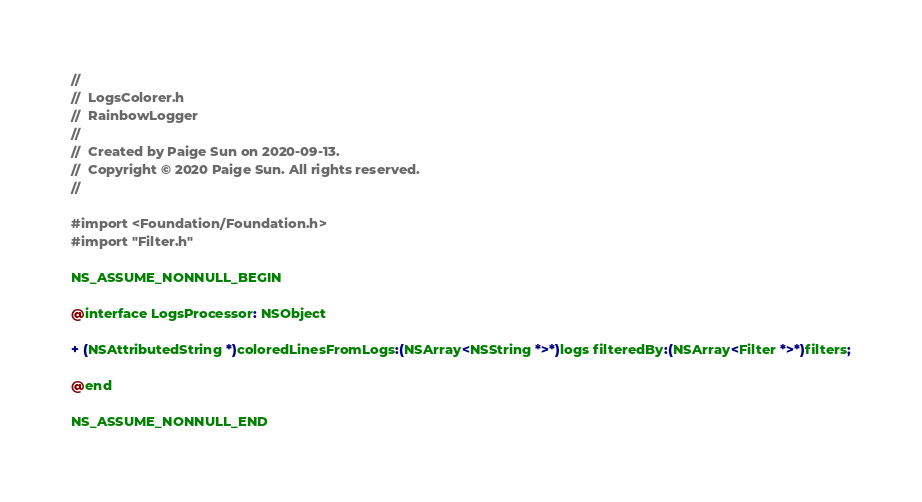Convert code to text. <code><loc_0><loc_0><loc_500><loc_500><_C_>//
//  LogsColorer.h
//  RainbowLogger
//
//  Created by Paige Sun on 2020-09-13.
//  Copyright © 2020 Paige Sun. All rights reserved.
//

#import <Foundation/Foundation.h>
#import "Filter.h"

NS_ASSUME_NONNULL_BEGIN

@interface LogsProcessor: NSObject

+ (NSAttributedString *)coloredLinesFromLogs:(NSArray<NSString *>*)logs filteredBy:(NSArray<Filter *>*)filters;

@end

NS_ASSUME_NONNULL_END
</code> 